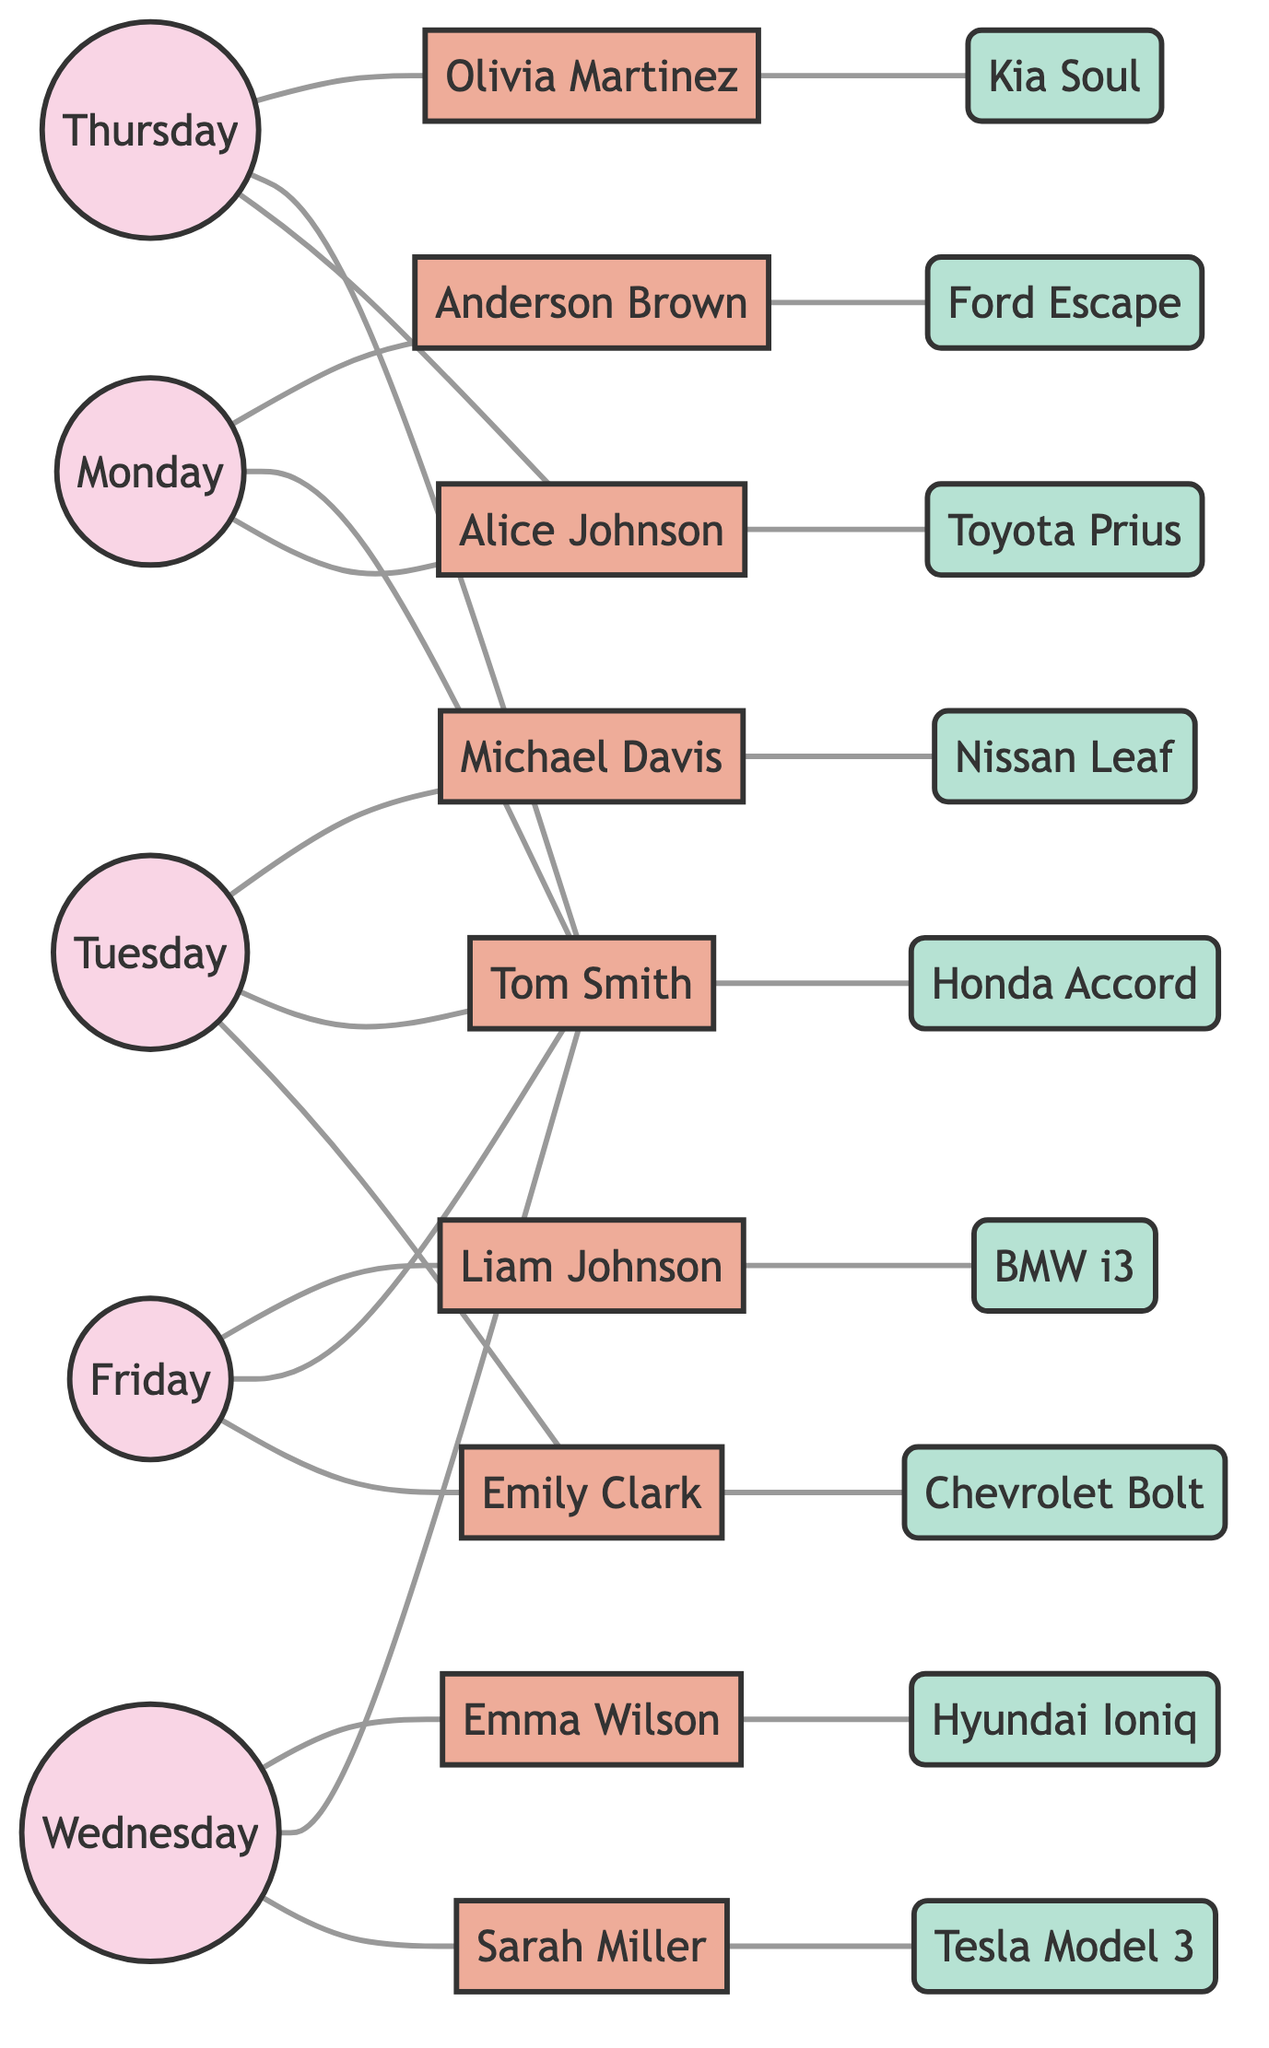What persons are carpooling on Monday? The diagram indicates that on Monday, the following individuals are involved in carpooling: Alice Johnson, Tom Smith, and Anderson Brown.
Answer: Alice Johnson, Tom Smith, Anderson Brown How many people are carpooling on Friday? Looking at the connections for Friday, we see three individuals participating in the carpool: Emily Clark, Tom Smith, and Liam Johnson.
Answer: 3 Which car belongs to Tom Smith? According to the diagram, Tom Smith is associated with the Honda Accord as his car.
Answer: Honda Accord Which days feature Tom Smith? The diagram shows that Tom Smith is involved in the carpool on Monday, Tuesday, Wednesday, Thursday, and Friday.
Answer: Monday, Tuesday, Wednesday, Thursday, Friday How many days are represented in this graph? The nodes labeled as days include Monday, Tuesday, Wednesday, Thursday, and Friday, representing a total of 5 distinct days.
Answer: 5 Who is the only person with a Toyota Prius? Examining the connections to the cars, we find that the Toyota Prius is owned solely by Alice Johnson.
Answer: Alice Johnson What is the relationship between Emily Clark and her car? The diagram establishes a direct connection between Emily Clark and the Chevrolet Bolt, indicating that this is her car.
Answer: Chevrolet Bolt How many cars are associated with people in the graph? By counting the unique cars linked to the individuals in the diagram, we observe there are 9 cars in total.
Answer: 9 What days does Alice Johnson participate in carpooling? Alice Johnson is shown to be part of the carpool on Monday and Thursday based on the edges that connect her to these days.
Answer: Monday, Thursday Which person drives the BMW i3? The diagram indicates that Liam Johnson is connected to the BMW i3, confirming that he drives this car.
Answer: Liam Johnson 